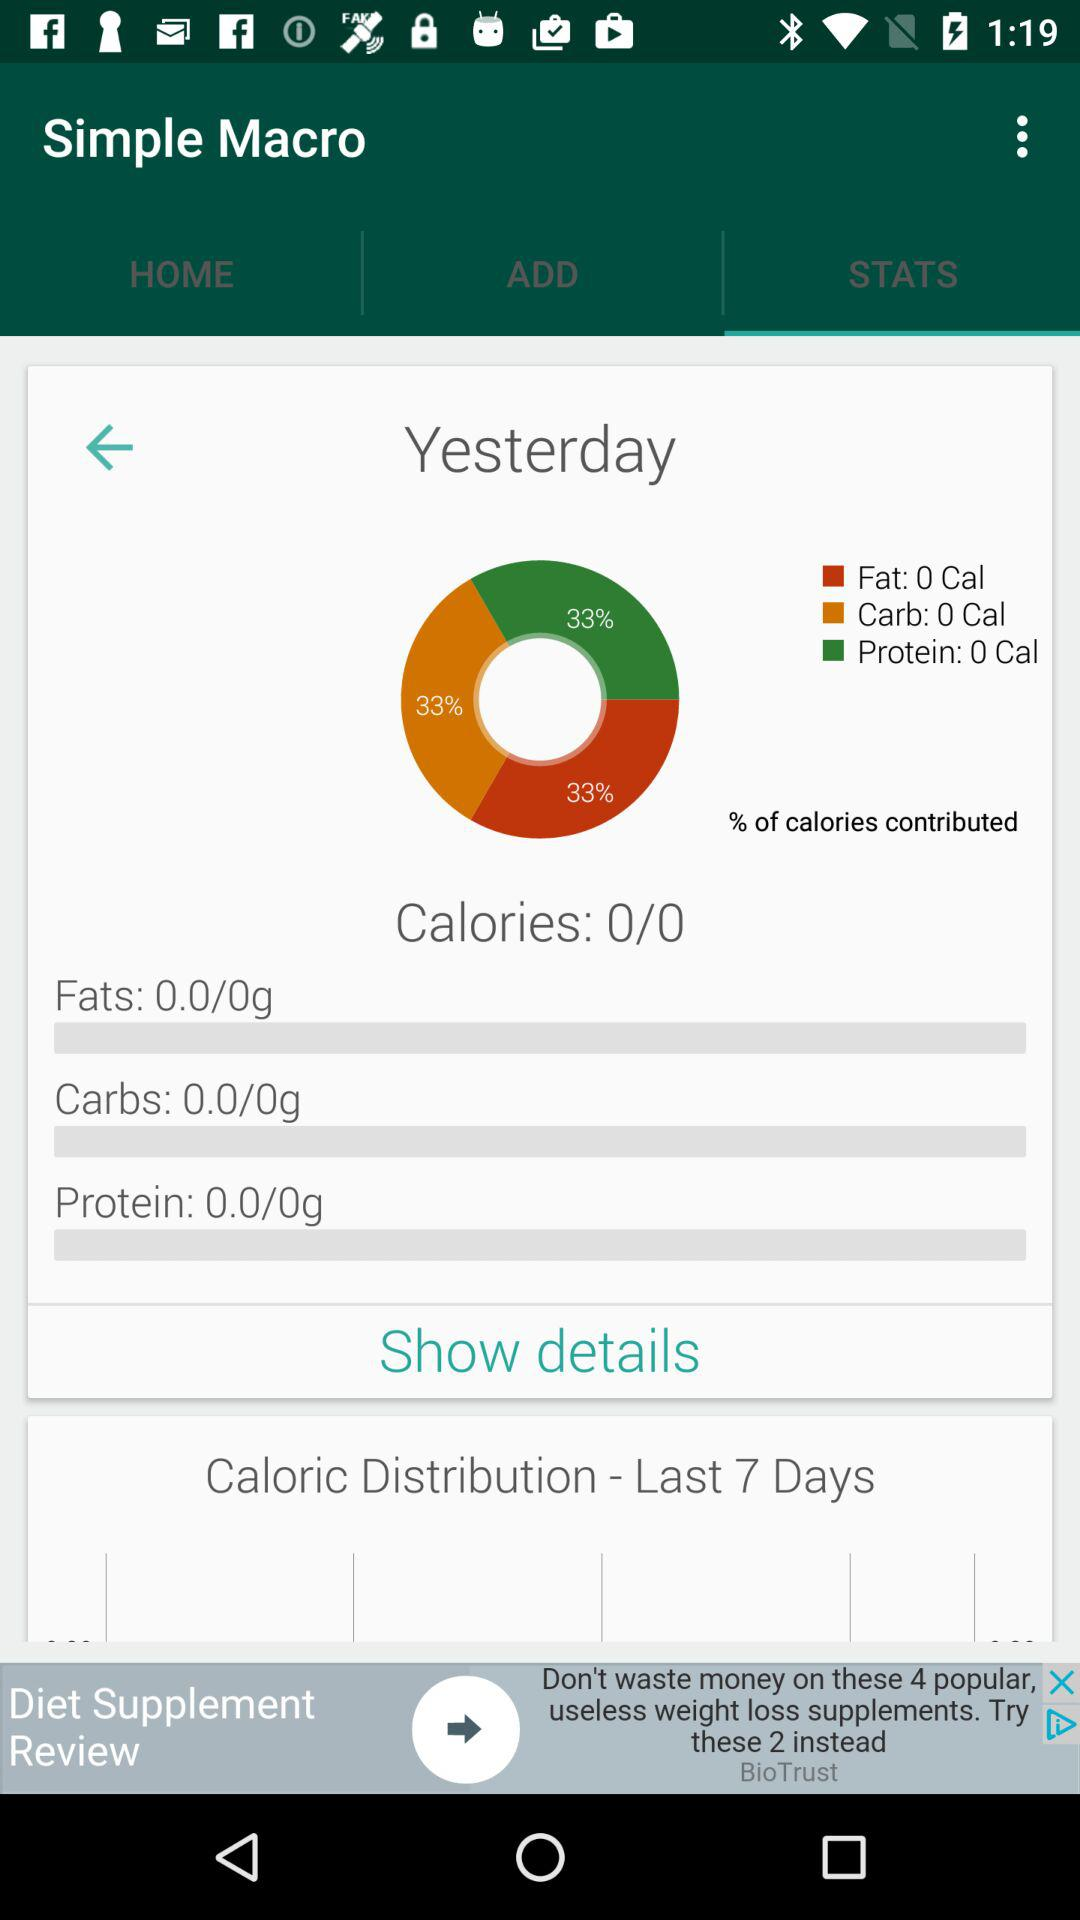What is the percentage of calories that come from fat?
Answer the question using a single word or phrase. 33% 